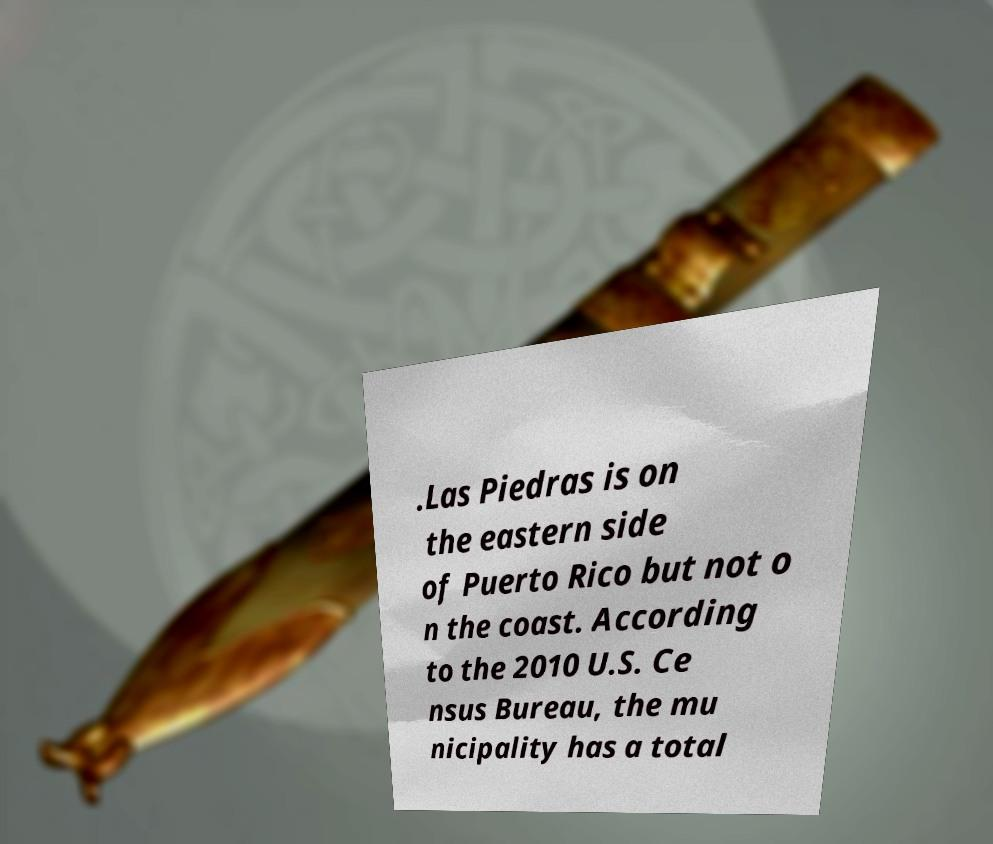I need the written content from this picture converted into text. Can you do that? .Las Piedras is on the eastern side of Puerto Rico but not o n the coast. According to the 2010 U.S. Ce nsus Bureau, the mu nicipality has a total 